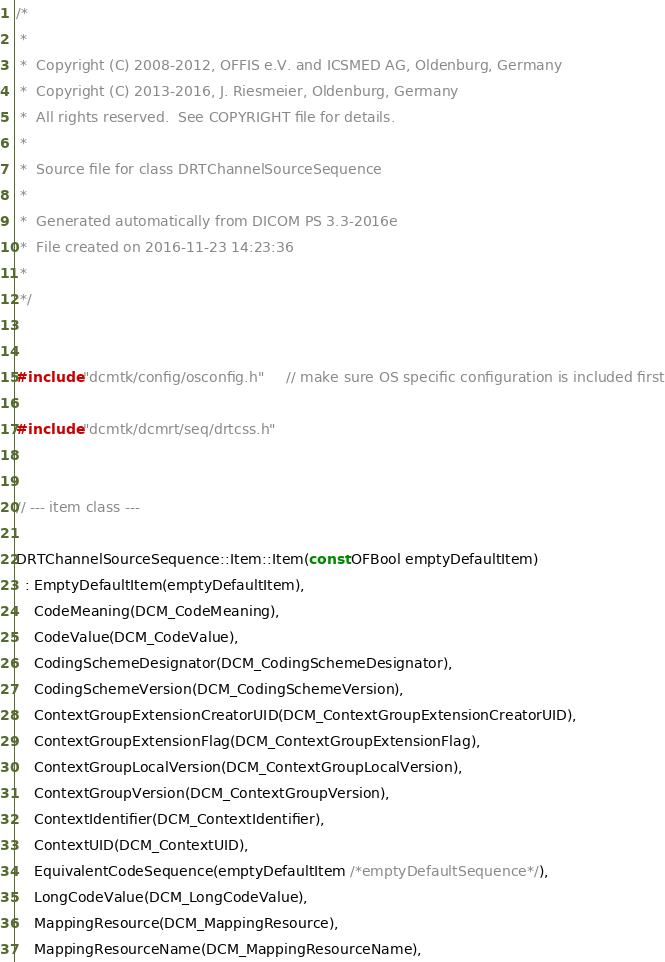Convert code to text. <code><loc_0><loc_0><loc_500><loc_500><_C++_>/*
 *
 *  Copyright (C) 2008-2012, OFFIS e.V. and ICSMED AG, Oldenburg, Germany
 *  Copyright (C) 2013-2016, J. Riesmeier, Oldenburg, Germany
 *  All rights reserved.  See COPYRIGHT file for details.
 *
 *  Source file for class DRTChannelSourceSequence
 *
 *  Generated automatically from DICOM PS 3.3-2016e
 *  File created on 2016-11-23 14:23:36
 *
 */


#include "dcmtk/config/osconfig.h"     // make sure OS specific configuration is included first

#include "dcmtk/dcmrt/seq/drtcss.h"


// --- item class ---

DRTChannelSourceSequence::Item::Item(const OFBool emptyDefaultItem)
  : EmptyDefaultItem(emptyDefaultItem),
    CodeMeaning(DCM_CodeMeaning),
    CodeValue(DCM_CodeValue),
    CodingSchemeDesignator(DCM_CodingSchemeDesignator),
    CodingSchemeVersion(DCM_CodingSchemeVersion),
    ContextGroupExtensionCreatorUID(DCM_ContextGroupExtensionCreatorUID),
    ContextGroupExtensionFlag(DCM_ContextGroupExtensionFlag),
    ContextGroupLocalVersion(DCM_ContextGroupLocalVersion),
    ContextGroupVersion(DCM_ContextGroupVersion),
    ContextIdentifier(DCM_ContextIdentifier),
    ContextUID(DCM_ContextUID),
    EquivalentCodeSequence(emptyDefaultItem /*emptyDefaultSequence*/),
    LongCodeValue(DCM_LongCodeValue),
    MappingResource(DCM_MappingResource),
    MappingResourceName(DCM_MappingResourceName),</code> 